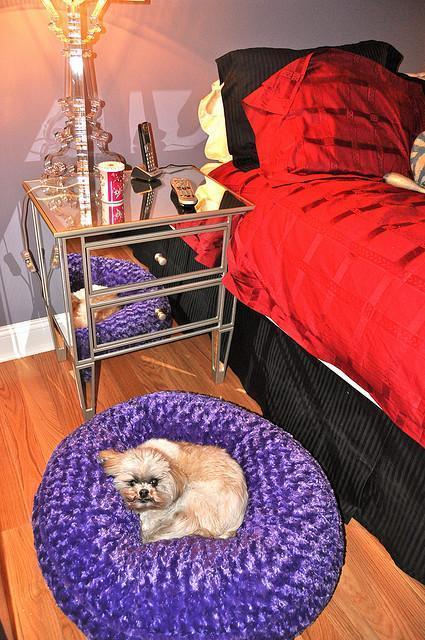How many beds are there?
Give a very brief answer. 2. 